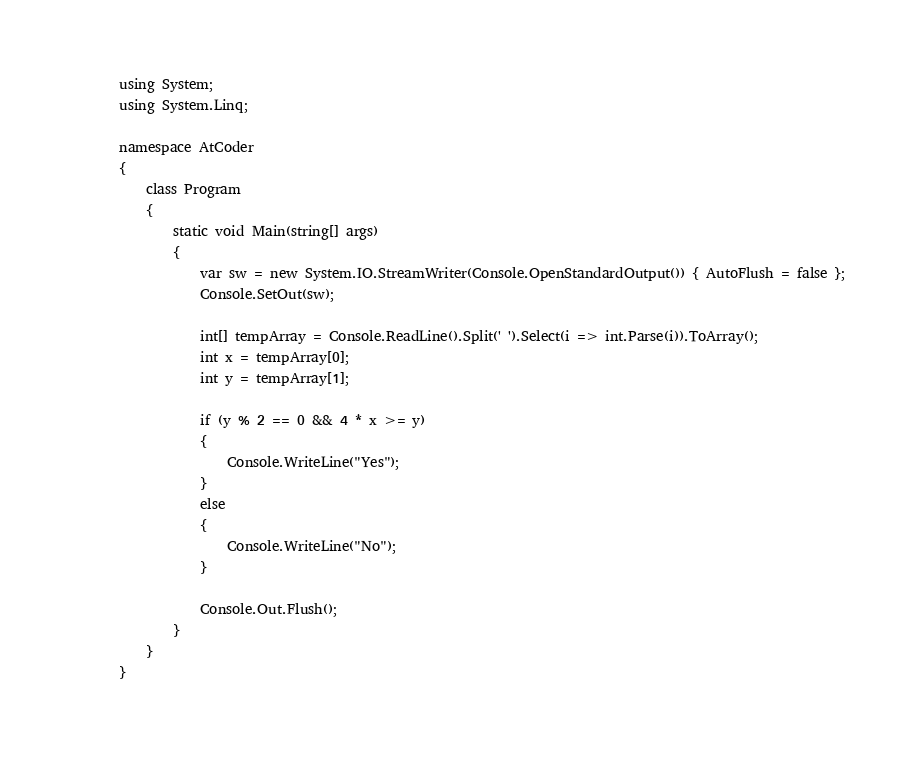<code> <loc_0><loc_0><loc_500><loc_500><_C#_>using System;
using System.Linq;

namespace AtCoder
{
    class Program
    {
        static void Main(string[] args)
        {
            var sw = new System.IO.StreamWriter(Console.OpenStandardOutput()) { AutoFlush = false };
            Console.SetOut(sw);

            int[] tempArray = Console.ReadLine().Split(' ').Select(i => int.Parse(i)).ToArray();
            int x = tempArray[0];
            int y = tempArray[1];

            if (y % 2 == 0 && 4 * x >= y)
            {
                Console.WriteLine("Yes");
            }
            else
            {
                Console.WriteLine("No");
            }

            Console.Out.Flush();
        }
    }
}</code> 